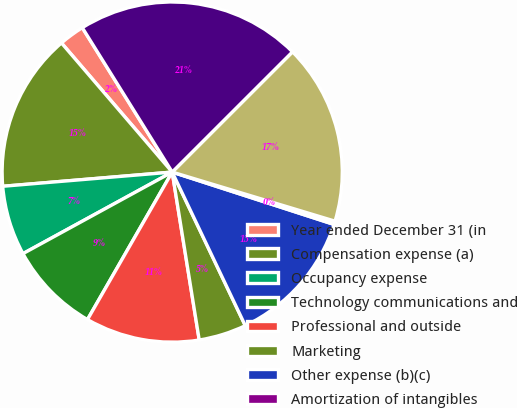Convert chart to OTSL. <chart><loc_0><loc_0><loc_500><loc_500><pie_chart><fcel>Year ended December 31 (in<fcel>Compensation expense (a)<fcel>Occupancy expense<fcel>Technology communications and<fcel>Professional and outside<fcel>Marketing<fcel>Other expense (b)(c)<fcel>Amortization of intangibles<fcel>Total noncompensation expense<fcel>Total noninterest expense<nl><fcel>2.42%<fcel>15.05%<fcel>6.63%<fcel>8.74%<fcel>10.84%<fcel>4.53%<fcel>12.95%<fcel>0.32%<fcel>17.16%<fcel>21.37%<nl></chart> 